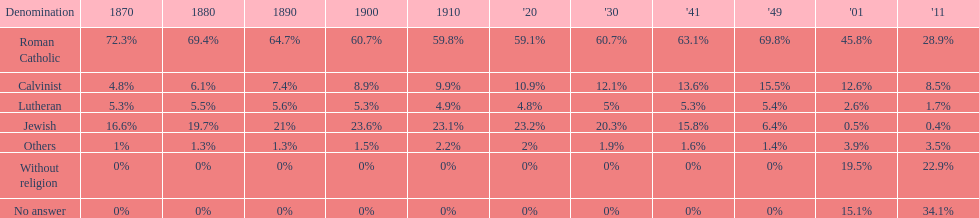In which year was the percentage of those without religion at least 20%? 2011. 